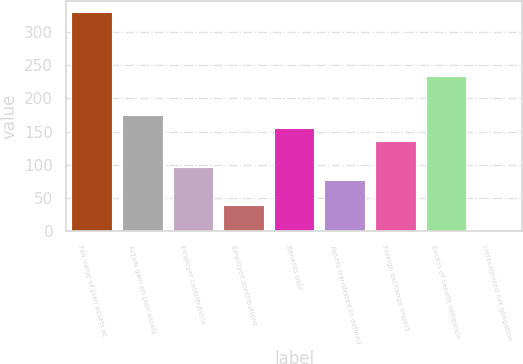Convert chart. <chart><loc_0><loc_0><loc_500><loc_500><bar_chart><fcel>Fair value of plan assets at<fcel>Actual gain on plan assets<fcel>Employer contributions<fcel>Employee contributions<fcel>Benefits paid<fcel>Assets transferred to defined<fcel>Foreign exchange impact<fcel>Excess of benefit obligation<fcel>Unrecognized net obligation<nl><fcel>330.41<fcel>174.97<fcel>97.25<fcel>38.96<fcel>155.54<fcel>77.82<fcel>136.11<fcel>233.26<fcel>0.1<nl></chart> 